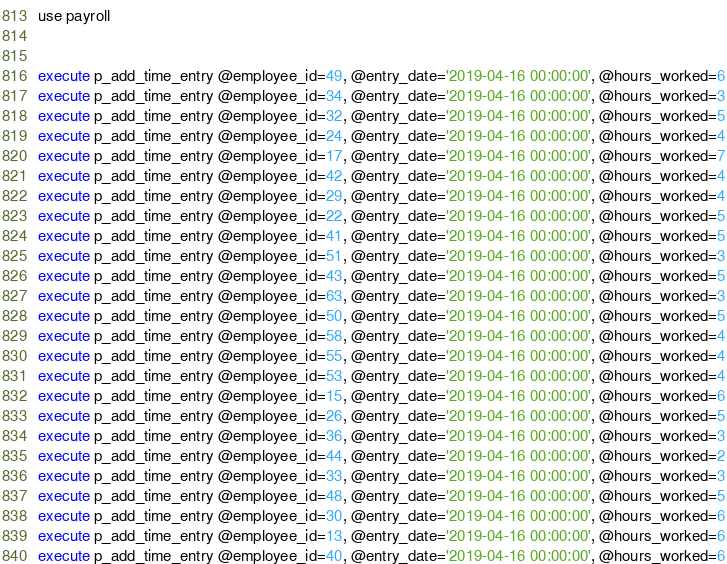Convert code to text. <code><loc_0><loc_0><loc_500><loc_500><_SQL_>use payroll


execute p_add_time_entry @employee_id=49, @entry_date='2019-04-16 00:00:00', @hours_worked=6
execute p_add_time_entry @employee_id=34, @entry_date='2019-04-16 00:00:00', @hours_worked=3
execute p_add_time_entry @employee_id=32, @entry_date='2019-04-16 00:00:00', @hours_worked=5
execute p_add_time_entry @employee_id=24, @entry_date='2019-04-16 00:00:00', @hours_worked=4
execute p_add_time_entry @employee_id=17, @entry_date='2019-04-16 00:00:00', @hours_worked=7
execute p_add_time_entry @employee_id=42, @entry_date='2019-04-16 00:00:00', @hours_worked=4
execute p_add_time_entry @employee_id=29, @entry_date='2019-04-16 00:00:00', @hours_worked=4
execute p_add_time_entry @employee_id=22, @entry_date='2019-04-16 00:00:00', @hours_worked=5
execute p_add_time_entry @employee_id=41, @entry_date='2019-04-16 00:00:00', @hours_worked=5
execute p_add_time_entry @employee_id=51, @entry_date='2019-04-16 00:00:00', @hours_worked=3
execute p_add_time_entry @employee_id=43, @entry_date='2019-04-16 00:00:00', @hours_worked=5
execute p_add_time_entry @employee_id=63, @entry_date='2019-04-16 00:00:00', @hours_worked=3
execute p_add_time_entry @employee_id=50, @entry_date='2019-04-16 00:00:00', @hours_worked=5
execute p_add_time_entry @employee_id=58, @entry_date='2019-04-16 00:00:00', @hours_worked=4
execute p_add_time_entry @employee_id=55, @entry_date='2019-04-16 00:00:00', @hours_worked=4
execute p_add_time_entry @employee_id=53, @entry_date='2019-04-16 00:00:00', @hours_worked=4
execute p_add_time_entry @employee_id=15, @entry_date='2019-04-16 00:00:00', @hours_worked=6
execute p_add_time_entry @employee_id=26, @entry_date='2019-04-16 00:00:00', @hours_worked=5
execute p_add_time_entry @employee_id=36, @entry_date='2019-04-16 00:00:00', @hours_worked=3
execute p_add_time_entry @employee_id=44, @entry_date='2019-04-16 00:00:00', @hours_worked=2
execute p_add_time_entry @employee_id=33, @entry_date='2019-04-16 00:00:00', @hours_worked=3
execute p_add_time_entry @employee_id=48, @entry_date='2019-04-16 00:00:00', @hours_worked=5
execute p_add_time_entry @employee_id=30, @entry_date='2019-04-16 00:00:00', @hours_worked=6
execute p_add_time_entry @employee_id=13, @entry_date='2019-04-16 00:00:00', @hours_worked=6
execute p_add_time_entry @employee_id=40, @entry_date='2019-04-16 00:00:00', @hours_worked=6

</code> 